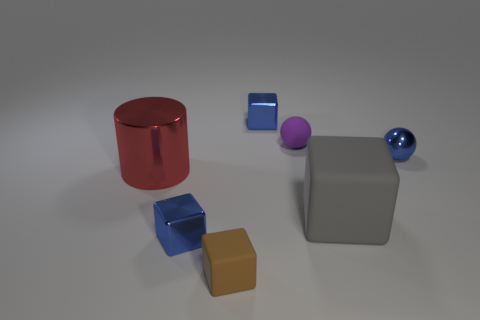Subtract all tiny blocks. How many blocks are left? 1 Subtract all brown balls. How many brown cubes are left? 1 Subtract all brown blocks. How many blocks are left? 3 Subtract 0 red blocks. How many objects are left? 7 Subtract all balls. How many objects are left? 5 Subtract 1 cylinders. How many cylinders are left? 0 Subtract all red spheres. Subtract all brown cubes. How many spheres are left? 2 Subtract all yellow balls. Subtract all cylinders. How many objects are left? 6 Add 6 gray cubes. How many gray cubes are left? 7 Add 3 large gray cubes. How many large gray cubes exist? 4 